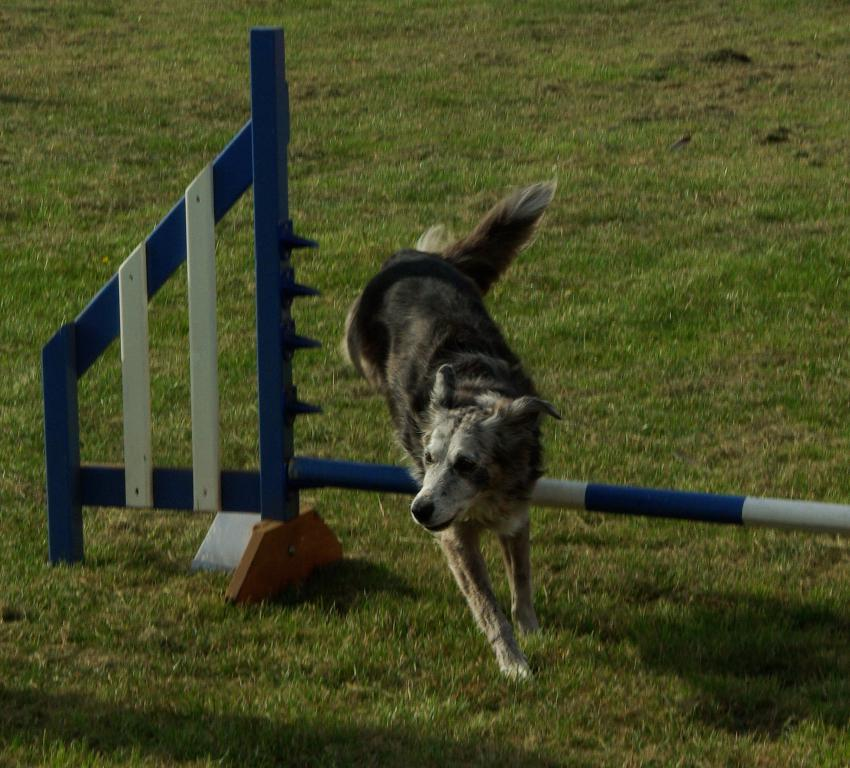What animal can be seen in the image? There is a dog in the image. What is the dog doing in the image? The dog is running. What other object is present in the image? There is a pole in the image. What colors are the pole? The pole is blue and white in color. What type of surface is visible in the image? There is grass visible in the image. Why is the dog crying in the image? There is no indication in the image that the dog is crying; it is running and appears to be happy. 